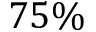Convert formula to latex. <formula><loc_0><loc_0><loc_500><loc_500>7 5 \%</formula> 